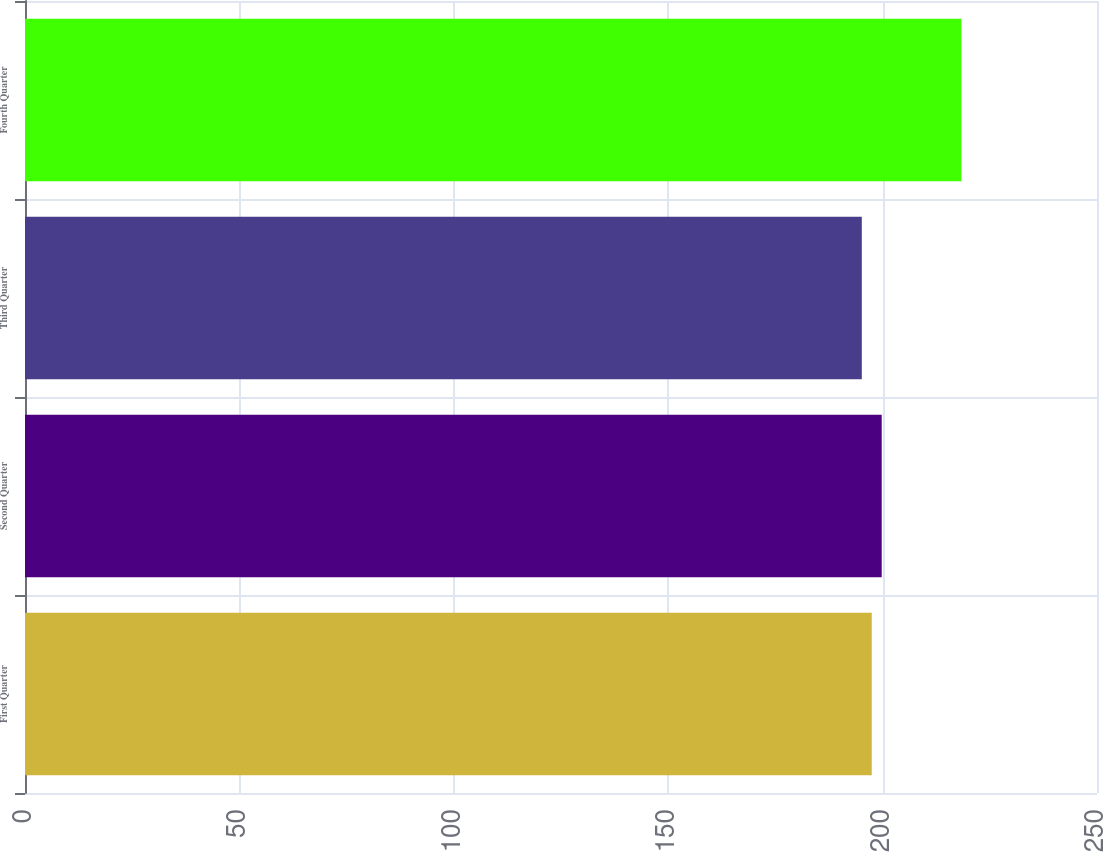Convert chart to OTSL. <chart><loc_0><loc_0><loc_500><loc_500><bar_chart><fcel>First Quarter<fcel>Second Quarter<fcel>Third Quarter<fcel>Fourth Quarter<nl><fcel>197.47<fcel>199.79<fcel>195.15<fcel>218.38<nl></chart> 